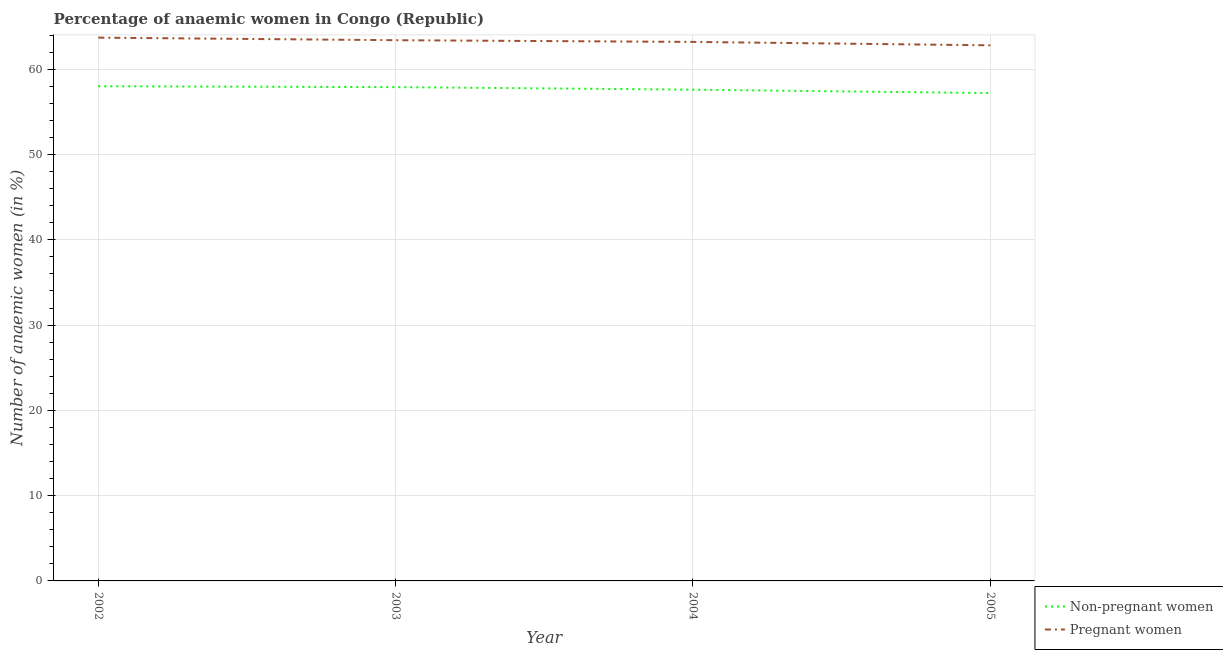How many different coloured lines are there?
Provide a succinct answer. 2. Does the line corresponding to percentage of pregnant anaemic women intersect with the line corresponding to percentage of non-pregnant anaemic women?
Ensure brevity in your answer.  No. Is the number of lines equal to the number of legend labels?
Ensure brevity in your answer.  Yes. What is the percentage of pregnant anaemic women in 2004?
Give a very brief answer. 63.2. Across all years, what is the maximum percentage of non-pregnant anaemic women?
Provide a succinct answer. 58. Across all years, what is the minimum percentage of pregnant anaemic women?
Keep it short and to the point. 62.8. In which year was the percentage of pregnant anaemic women maximum?
Your answer should be very brief. 2002. In which year was the percentage of pregnant anaemic women minimum?
Offer a terse response. 2005. What is the total percentage of pregnant anaemic women in the graph?
Your answer should be very brief. 253.1. What is the difference between the percentage of non-pregnant anaemic women in 2003 and that in 2005?
Your answer should be very brief. 0.7. What is the difference between the percentage of pregnant anaemic women in 2003 and the percentage of non-pregnant anaemic women in 2002?
Make the answer very short. 5.4. What is the average percentage of non-pregnant anaemic women per year?
Provide a succinct answer. 57.67. In the year 2002, what is the difference between the percentage of non-pregnant anaemic women and percentage of pregnant anaemic women?
Your answer should be compact. -5.7. What is the ratio of the percentage of non-pregnant anaemic women in 2002 to that in 2003?
Provide a short and direct response. 1. What is the difference between the highest and the second highest percentage of non-pregnant anaemic women?
Your answer should be very brief. 0.1. What is the difference between the highest and the lowest percentage of non-pregnant anaemic women?
Provide a succinct answer. 0.8. How many years are there in the graph?
Your answer should be compact. 4. Are the values on the major ticks of Y-axis written in scientific E-notation?
Your answer should be compact. No. Does the graph contain any zero values?
Keep it short and to the point. No. Does the graph contain grids?
Make the answer very short. Yes. Where does the legend appear in the graph?
Provide a succinct answer. Bottom right. How many legend labels are there?
Your answer should be very brief. 2. What is the title of the graph?
Keep it short and to the point. Percentage of anaemic women in Congo (Republic). Does "Measles" appear as one of the legend labels in the graph?
Give a very brief answer. No. What is the label or title of the X-axis?
Your answer should be compact. Year. What is the label or title of the Y-axis?
Provide a succinct answer. Number of anaemic women (in %). What is the Number of anaemic women (in %) in Pregnant women in 2002?
Your answer should be very brief. 63.7. What is the Number of anaemic women (in %) in Non-pregnant women in 2003?
Your answer should be very brief. 57.9. What is the Number of anaemic women (in %) in Pregnant women in 2003?
Make the answer very short. 63.4. What is the Number of anaemic women (in %) of Non-pregnant women in 2004?
Make the answer very short. 57.6. What is the Number of anaemic women (in %) of Pregnant women in 2004?
Your answer should be compact. 63.2. What is the Number of anaemic women (in %) of Non-pregnant women in 2005?
Keep it short and to the point. 57.2. What is the Number of anaemic women (in %) of Pregnant women in 2005?
Offer a very short reply. 62.8. Across all years, what is the maximum Number of anaemic women (in %) of Non-pregnant women?
Ensure brevity in your answer.  58. Across all years, what is the maximum Number of anaemic women (in %) of Pregnant women?
Make the answer very short. 63.7. Across all years, what is the minimum Number of anaemic women (in %) of Non-pregnant women?
Offer a very short reply. 57.2. Across all years, what is the minimum Number of anaemic women (in %) of Pregnant women?
Make the answer very short. 62.8. What is the total Number of anaemic women (in %) in Non-pregnant women in the graph?
Your response must be concise. 230.7. What is the total Number of anaemic women (in %) of Pregnant women in the graph?
Make the answer very short. 253.1. What is the difference between the Number of anaemic women (in %) in Non-pregnant women in 2002 and that in 2003?
Offer a terse response. 0.1. What is the difference between the Number of anaemic women (in %) of Pregnant women in 2002 and that in 2005?
Your response must be concise. 0.9. What is the difference between the Number of anaemic women (in %) in Non-pregnant women in 2003 and that in 2004?
Keep it short and to the point. 0.3. What is the difference between the Number of anaemic women (in %) in Pregnant women in 2003 and that in 2004?
Make the answer very short. 0.2. What is the difference between the Number of anaemic women (in %) in Non-pregnant women in 2003 and that in 2005?
Keep it short and to the point. 0.7. What is the difference between the Number of anaemic women (in %) in Non-pregnant women in 2004 and that in 2005?
Ensure brevity in your answer.  0.4. What is the difference between the Number of anaemic women (in %) in Non-pregnant women in 2002 and the Number of anaemic women (in %) in Pregnant women in 2003?
Your answer should be compact. -5.4. What is the difference between the Number of anaemic women (in %) of Non-pregnant women in 2002 and the Number of anaemic women (in %) of Pregnant women in 2005?
Provide a short and direct response. -4.8. What is the difference between the Number of anaemic women (in %) of Non-pregnant women in 2003 and the Number of anaemic women (in %) of Pregnant women in 2004?
Offer a terse response. -5.3. What is the difference between the Number of anaemic women (in %) of Non-pregnant women in 2003 and the Number of anaemic women (in %) of Pregnant women in 2005?
Offer a very short reply. -4.9. What is the difference between the Number of anaemic women (in %) in Non-pregnant women in 2004 and the Number of anaemic women (in %) in Pregnant women in 2005?
Your answer should be very brief. -5.2. What is the average Number of anaemic women (in %) in Non-pregnant women per year?
Offer a terse response. 57.67. What is the average Number of anaemic women (in %) in Pregnant women per year?
Provide a succinct answer. 63.27. In the year 2003, what is the difference between the Number of anaemic women (in %) of Non-pregnant women and Number of anaemic women (in %) of Pregnant women?
Provide a short and direct response. -5.5. In the year 2004, what is the difference between the Number of anaemic women (in %) of Non-pregnant women and Number of anaemic women (in %) of Pregnant women?
Give a very brief answer. -5.6. What is the ratio of the Number of anaemic women (in %) of Non-pregnant women in 2002 to that in 2004?
Your answer should be compact. 1.01. What is the ratio of the Number of anaemic women (in %) of Pregnant women in 2002 to that in 2004?
Give a very brief answer. 1.01. What is the ratio of the Number of anaemic women (in %) of Non-pregnant women in 2002 to that in 2005?
Ensure brevity in your answer.  1.01. What is the ratio of the Number of anaemic women (in %) of Pregnant women in 2002 to that in 2005?
Your response must be concise. 1.01. What is the ratio of the Number of anaemic women (in %) of Non-pregnant women in 2003 to that in 2004?
Offer a very short reply. 1.01. What is the ratio of the Number of anaemic women (in %) of Pregnant women in 2003 to that in 2004?
Ensure brevity in your answer.  1. What is the ratio of the Number of anaemic women (in %) of Non-pregnant women in 2003 to that in 2005?
Offer a terse response. 1.01. What is the ratio of the Number of anaemic women (in %) in Pregnant women in 2003 to that in 2005?
Offer a terse response. 1.01. What is the ratio of the Number of anaemic women (in %) in Pregnant women in 2004 to that in 2005?
Make the answer very short. 1.01. What is the difference between the highest and the second highest Number of anaemic women (in %) of Non-pregnant women?
Provide a short and direct response. 0.1. What is the difference between the highest and the lowest Number of anaemic women (in %) in Non-pregnant women?
Your answer should be compact. 0.8. 